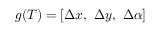Convert formula to latex. <formula><loc_0><loc_0><loc_500><loc_500>g ( T ) = [ \Delta x , \ \Delta y , \ \Delta \alpha ]</formula> 